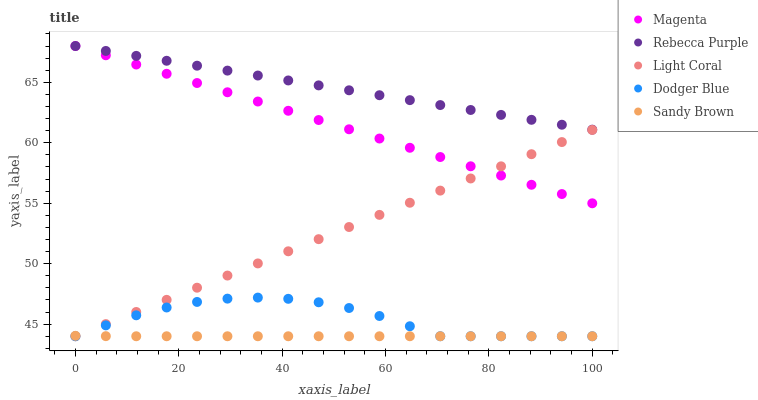Does Sandy Brown have the minimum area under the curve?
Answer yes or no. Yes. Does Rebecca Purple have the maximum area under the curve?
Answer yes or no. Yes. Does Magenta have the minimum area under the curve?
Answer yes or no. No. Does Magenta have the maximum area under the curve?
Answer yes or no. No. Is Magenta the smoothest?
Answer yes or no. Yes. Is Dodger Blue the roughest?
Answer yes or no. Yes. Is Sandy Brown the smoothest?
Answer yes or no. No. Is Sandy Brown the roughest?
Answer yes or no. No. Does Light Coral have the lowest value?
Answer yes or no. Yes. Does Magenta have the lowest value?
Answer yes or no. No. Does Rebecca Purple have the highest value?
Answer yes or no. Yes. Does Sandy Brown have the highest value?
Answer yes or no. No. Is Sandy Brown less than Magenta?
Answer yes or no. Yes. Is Magenta greater than Sandy Brown?
Answer yes or no. Yes. Does Magenta intersect Light Coral?
Answer yes or no. Yes. Is Magenta less than Light Coral?
Answer yes or no. No. Is Magenta greater than Light Coral?
Answer yes or no. No. Does Sandy Brown intersect Magenta?
Answer yes or no. No. 